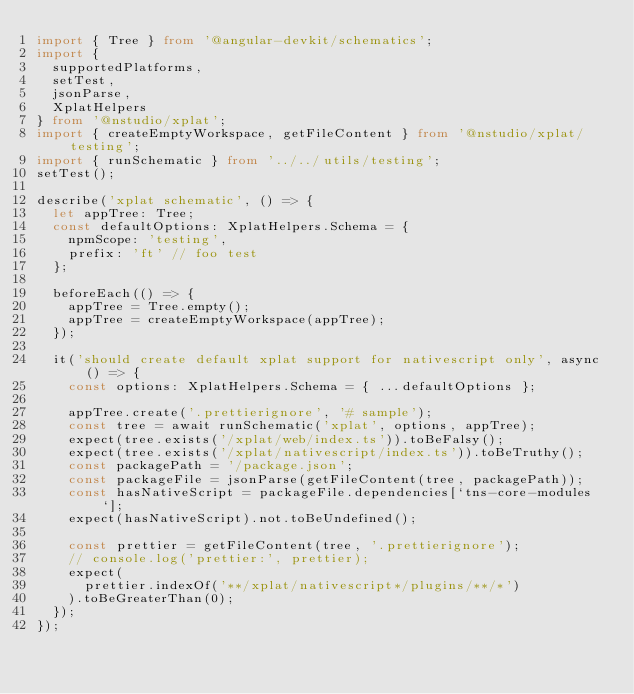<code> <loc_0><loc_0><loc_500><loc_500><_TypeScript_>import { Tree } from '@angular-devkit/schematics';
import {
  supportedPlatforms,
  setTest,
  jsonParse,
  XplatHelpers
} from '@nstudio/xplat';
import { createEmptyWorkspace, getFileContent } from '@nstudio/xplat/testing';
import { runSchematic } from '../../utils/testing';
setTest();

describe('xplat schematic', () => {
  let appTree: Tree;
  const defaultOptions: XplatHelpers.Schema = {
    npmScope: 'testing',
    prefix: 'ft' // foo test
  };

  beforeEach(() => {
    appTree = Tree.empty();
    appTree = createEmptyWorkspace(appTree);
  });

  it('should create default xplat support for nativescript only', async () => {
    const options: XplatHelpers.Schema = { ...defaultOptions };

    appTree.create('.prettierignore', '# sample');
    const tree = await runSchematic('xplat', options, appTree);
    expect(tree.exists('/xplat/web/index.ts')).toBeFalsy();
    expect(tree.exists('/xplat/nativescript/index.ts')).toBeTruthy();
    const packagePath = '/package.json';
    const packageFile = jsonParse(getFileContent(tree, packagePath));
    const hasNativeScript = packageFile.dependencies[`tns-core-modules`];
    expect(hasNativeScript).not.toBeUndefined();

    const prettier = getFileContent(tree, '.prettierignore');
    // console.log('prettier:', prettier);
    expect(
      prettier.indexOf('**/xplat/nativescript*/plugins/**/*')
    ).toBeGreaterThan(0);
  });
});
</code> 